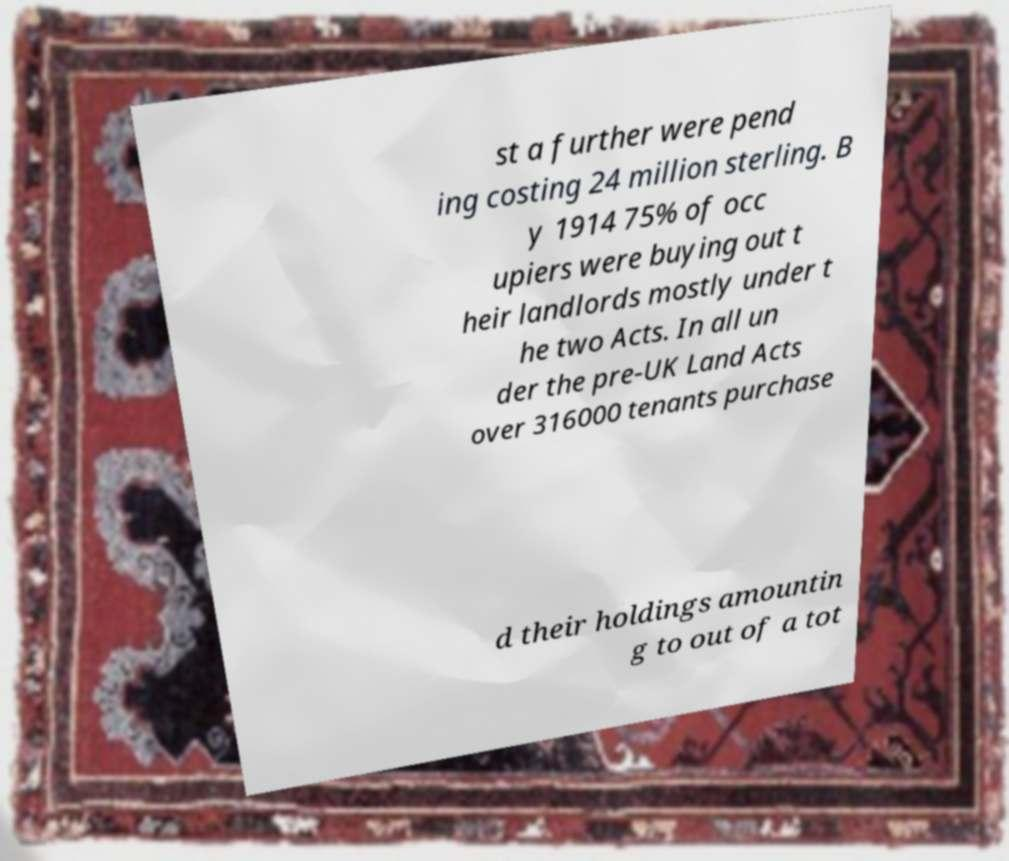For documentation purposes, I need the text within this image transcribed. Could you provide that? st a further were pend ing costing 24 million sterling. B y 1914 75% of occ upiers were buying out t heir landlords mostly under t he two Acts. In all un der the pre-UK Land Acts over 316000 tenants purchase d their holdings amountin g to out of a tot 